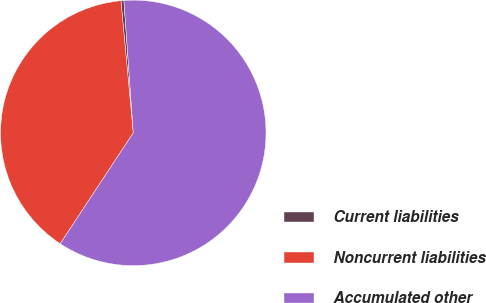<chart> <loc_0><loc_0><loc_500><loc_500><pie_chart><fcel>Current liabilities<fcel>Noncurrent liabilities<fcel>Accumulated other<nl><fcel>0.36%<fcel>39.24%<fcel>60.4%<nl></chart> 